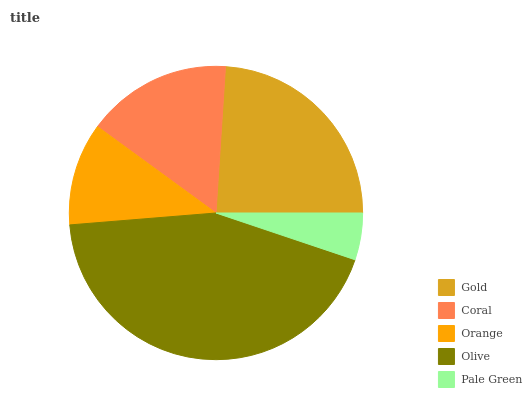Is Pale Green the minimum?
Answer yes or no. Yes. Is Olive the maximum?
Answer yes or no. Yes. Is Coral the minimum?
Answer yes or no. No. Is Coral the maximum?
Answer yes or no. No. Is Gold greater than Coral?
Answer yes or no. Yes. Is Coral less than Gold?
Answer yes or no. Yes. Is Coral greater than Gold?
Answer yes or no. No. Is Gold less than Coral?
Answer yes or no. No. Is Coral the high median?
Answer yes or no. Yes. Is Coral the low median?
Answer yes or no. Yes. Is Olive the high median?
Answer yes or no. No. Is Gold the low median?
Answer yes or no. No. 